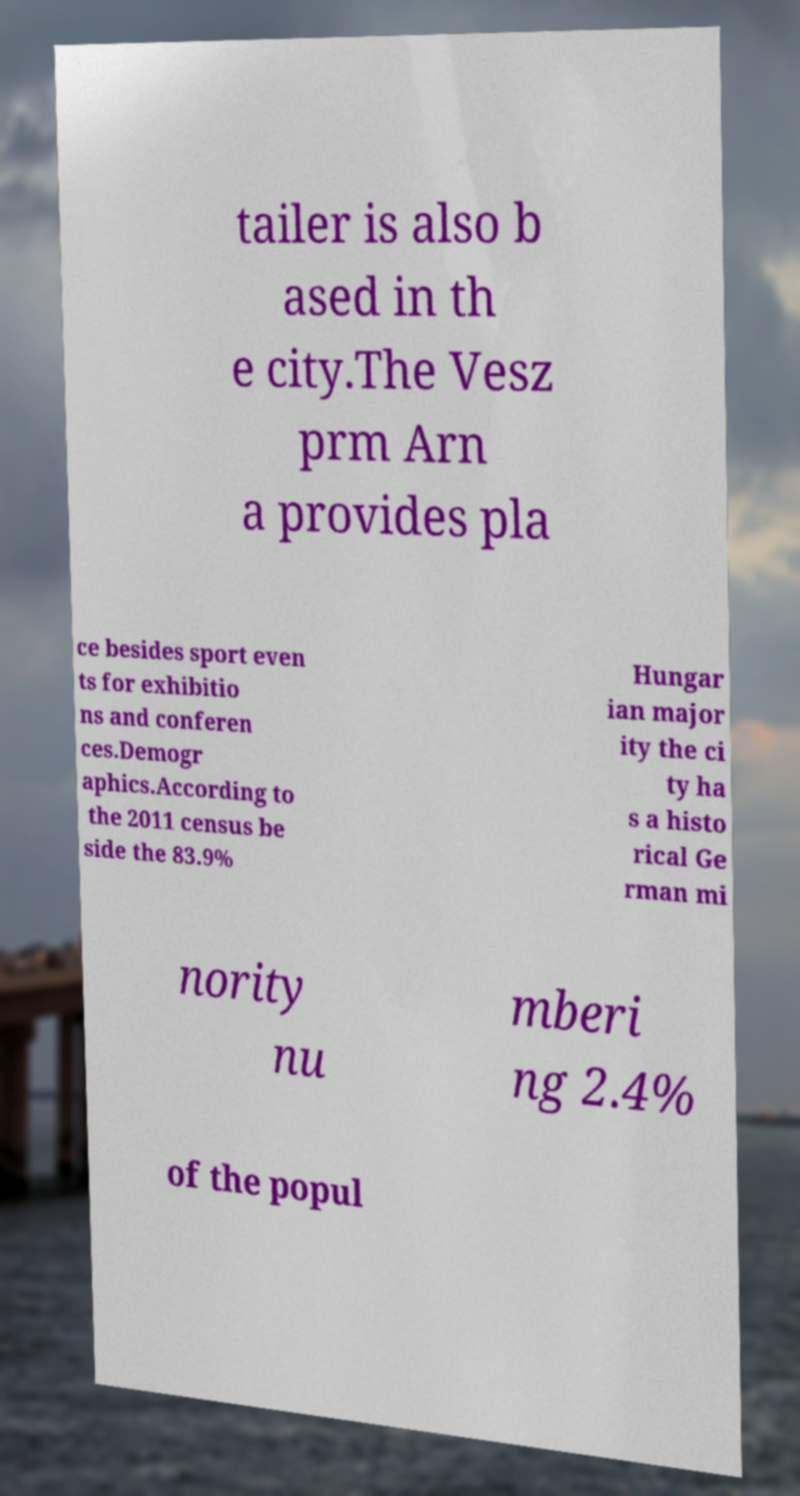Could you assist in decoding the text presented in this image and type it out clearly? tailer is also b ased in th e city.The Vesz prm Arn a provides pla ce besides sport even ts for exhibitio ns and conferen ces.Demogr aphics.According to the 2011 census be side the 83.9% Hungar ian major ity the ci ty ha s a histo rical Ge rman mi nority nu mberi ng 2.4% of the popul 